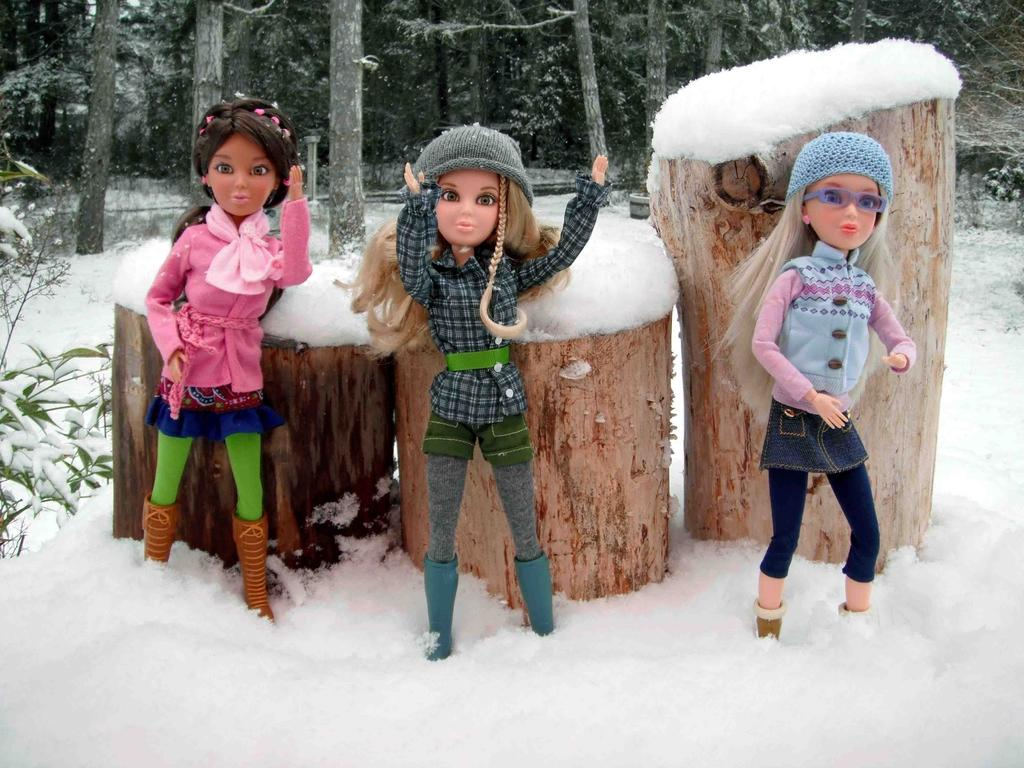How many Barbie dolls are present in the image? There are three Barbie dolls in the image. What are the Barbie dolls doing in the image? The Barbie dolls are standing in front of tree trunks. What is the setting of the image? The scene takes place on a snowy land. What can be seen in the background of the image? There are trees visible in the background of the image. What type of quill is the lawyer using to write a document in the image? There is no lawyer or quill present in the image; it features three Barbie dolls standing in front of tree trunks on a snowy land. 